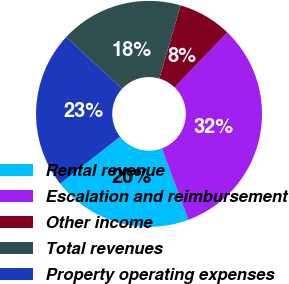<chart> <loc_0><loc_0><loc_500><loc_500><pie_chart><fcel>Rental revenue<fcel>Escalation and reimbursement<fcel>Other income<fcel>Total revenues<fcel>Property operating expenses<nl><fcel>20.06%<fcel>32.14%<fcel>7.68%<fcel>17.61%<fcel>22.51%<nl></chart> 